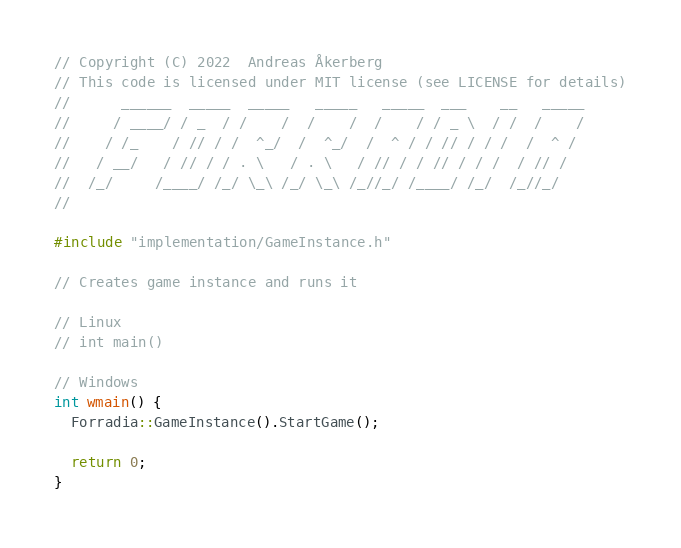Convert code to text. <code><loc_0><loc_0><loc_500><loc_500><_C++_>// Copyright (C) 2022  Andreas Åkerberg
// This code is licensed under MIT license (see LICENSE for details)
//      ______  _____  _____   _____   _____  ___    __   _____
//     / ____/ / _  / /    /  /    /  /    / / _ \  / /  /    /
//    / /_    / // / /  ^_/  /  ^_/  /  ^ / / // / / /  /  ^ /
//   / __/   / // / / . \   / . \   / // / / // / / /  / // /
//  /_/     /____/ /_/ \_\ /_/ \_\ /_//_/ /____/ /_/  /_//_/
//

#include "implementation/GameInstance.h"

// Creates game instance and runs it

// Linux
// int main()

// Windows
int wmain() {
  Forradia::GameInstance().StartGame();

  return 0;
}
</code> 